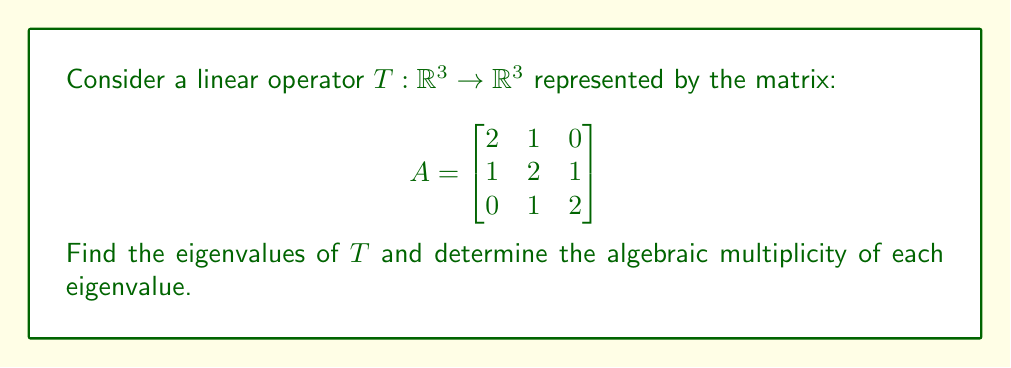Give your solution to this math problem. To find the eigenvalues and their algebraic multiplicities, we follow these steps:

1) Calculate the characteristic polynomial:
   $p(\lambda) = \det(A - \lambda I)$
   
   $$\det\begin{bmatrix}
   2-\lambda & 1 & 0 \\
   1 & 2-\lambda & 1 \\
   0 & 1 & 2-\lambda
   \end{bmatrix}$$

2) Expand the determinant:
   $p(\lambda) = (2-\lambda)[(2-\lambda)^2 - 1] - 1(1-0)$
   $= (2-\lambda)(4-4\lambda+\lambda^2 - 1) - 1$
   $= (2-\lambda)(3-4\lambda+\lambda^2) - 1$
   $= 6-8\lambda+2\lambda^2-3\lambda+4\lambda^2-\lambda^3 - 1$
   $= -\lambda^3 + 6\lambda^2 - 11\lambda + 5$

3) Factor the characteristic polynomial:
   $p(\lambda) = -(\lambda - 1)(\lambda - 2)(\lambda - 3)$

4) Identify the eigenvalues:
   The roots of $p(\lambda)$ are $\lambda_1 = 1$, $\lambda_2 = 2$, and $\lambda_3 = 3$

5) Determine the algebraic multiplicity of each eigenvalue:
   Each factor $(\lambda - 1)$, $(\lambda - 2)$, and $(\lambda - 3)$ appears once in the factored polynomial. Therefore, the algebraic multiplicity of each eigenvalue is 1.
Answer: Eigenvalues: 1, 2, 3; Algebraic multiplicities: 1, 1, 1 